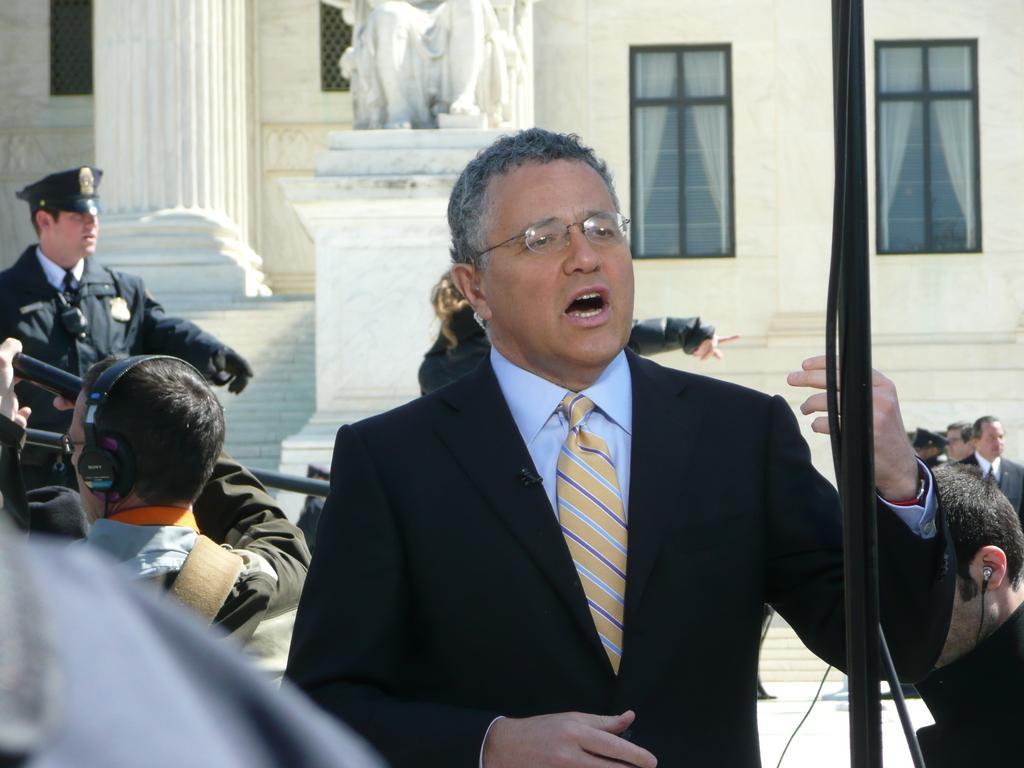Can you describe this image briefly? In this picture, we see a man in the black blazer is standing. He is wearing the spectacles and he is trying to talk something. Behind him, we see a person. Beside him, we see a man is standing. Behind the man, we see the people are standing. On the left side, we see a man is wearing the spectacles and a headset. In front of him, we see a man in the uniform is standing. In the middle, we see the statues. Beside that, we see the staircase. In the background, we see a building, pillar, curtains and the windows. 